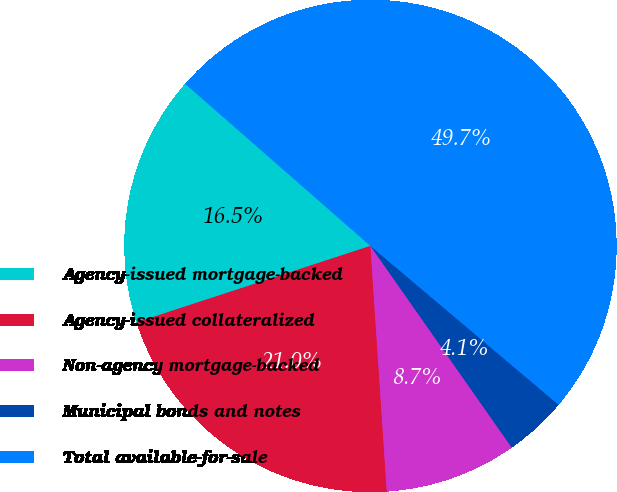Convert chart to OTSL. <chart><loc_0><loc_0><loc_500><loc_500><pie_chart><fcel>Agency-issued mortgage-backed<fcel>Agency-issued collateralized<fcel>Non-agency mortgage-backed<fcel>Municipal bonds and notes<fcel>Total available-for-sale<nl><fcel>16.47%<fcel>21.03%<fcel>8.67%<fcel>4.11%<fcel>49.72%<nl></chart> 